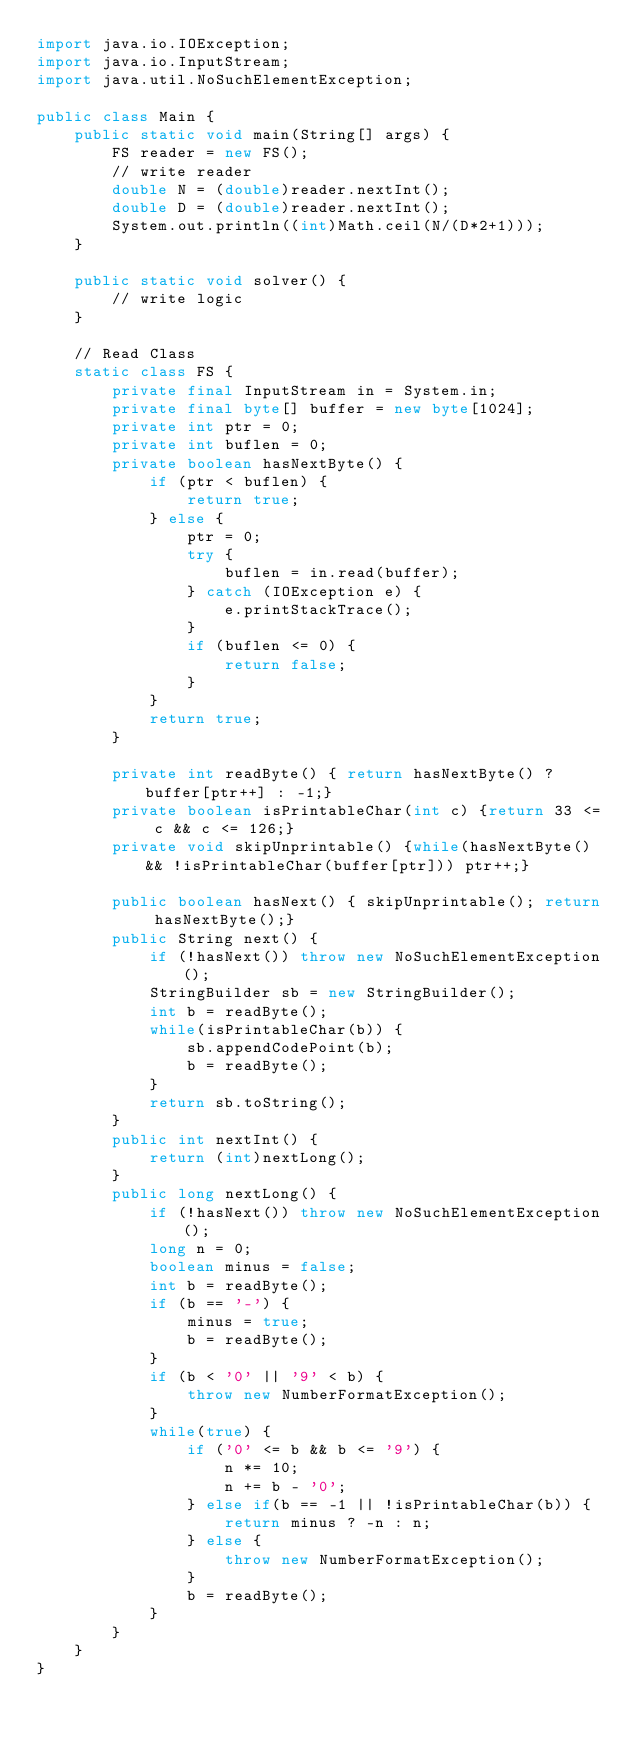<code> <loc_0><loc_0><loc_500><loc_500><_Java_>import java.io.IOException;
import java.io.InputStream;
import java.util.NoSuchElementException;

public class Main {
	public static void main(String[] args) {
		FS reader = new FS();
		// write reader
		double N = (double)reader.nextInt();
		double D = (double)reader.nextInt();
		System.out.println((int)Math.ceil(N/(D*2+1)));
	}
	
	public static void solver() {
		// write logic
	}
	
	// Read Class
	static class FS {
		private final InputStream in = System.in;
		private final byte[] buffer = new byte[1024];
		private int ptr = 0;
		private int buflen = 0;
		private boolean hasNextByte() {
			if (ptr < buflen) {
				return true;
			} else {
				ptr = 0;
				try {
					buflen = in.read(buffer);
				} catch (IOException e) {
					e.printStackTrace();
				}
				if (buflen <= 0) {
					return false;
				}
			}
			return true;
		}
	
		private int readByte() { return hasNextByte() ? buffer[ptr++] : -1;}
		private boolean isPrintableChar(int c) {return 33 <= c && c <= 126;}
		private void skipUnprintable() {while(hasNextByte() && !isPrintableChar(buffer[ptr])) ptr++;}
	
		public boolean hasNext() { skipUnprintable(); return hasNextByte();}
		public String next() {
			if (!hasNext()) throw new NoSuchElementException();
			StringBuilder sb = new StringBuilder();
			int b = readByte();
			while(isPrintableChar(b)) {
				sb.appendCodePoint(b);
				b = readByte();
			}
			return sb.toString();
		}
		public int nextInt() {
			return (int)nextLong();
		}
		public long nextLong() {
			if (!hasNext()) throw new NoSuchElementException();
			long n = 0;
			boolean minus = false;
			int b = readByte();
			if (b == '-') {
				minus = true;
				b = readByte();
			}
			if (b < '0' || '9' < b) {
				throw new NumberFormatException();
			}
			while(true) {
				if ('0' <= b && b <= '9') {
					n *= 10;
					n += b - '0';
				} else if(b == -1 || !isPrintableChar(b)) {
					return minus ? -n : n;
				} else {
					throw new NumberFormatException();
				}
				b = readByte();
			}
		}
	}
}
</code> 